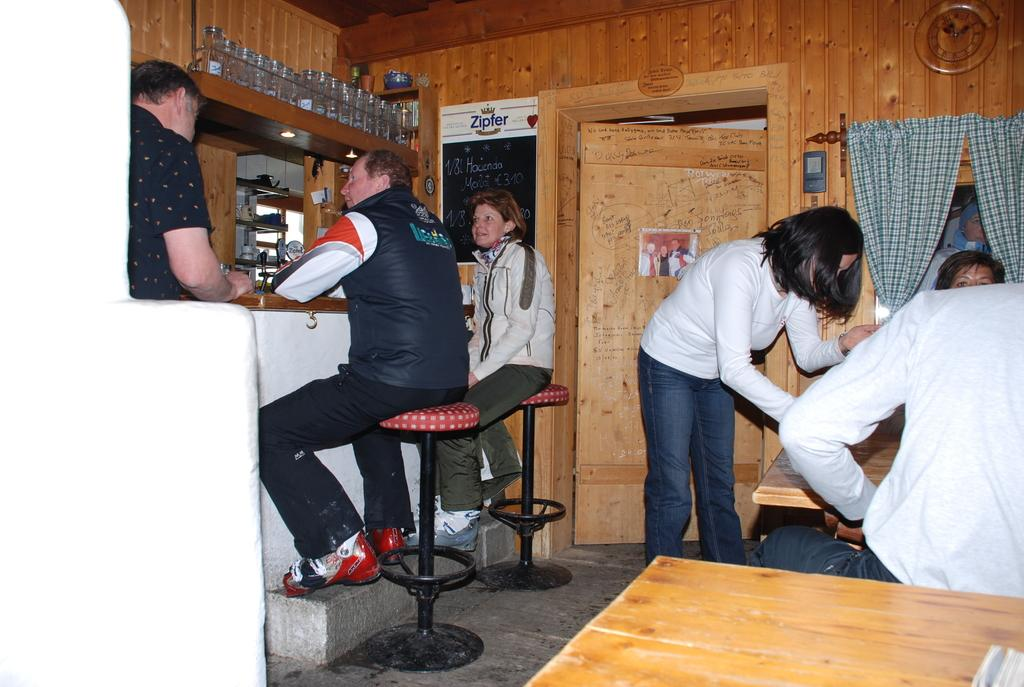How many people are sitting in the scene? There are two persons sitting on stools in the scene. What can be seen in the middle of the scene? There is a door in the middle of the scene. What is the woman doing at the right side? The woman is standing at the right side. What type of iron is the woman using to exercise her muscles in the image? There is no iron or exercise equipment present in the image. The woman is simply standing at the right side. 